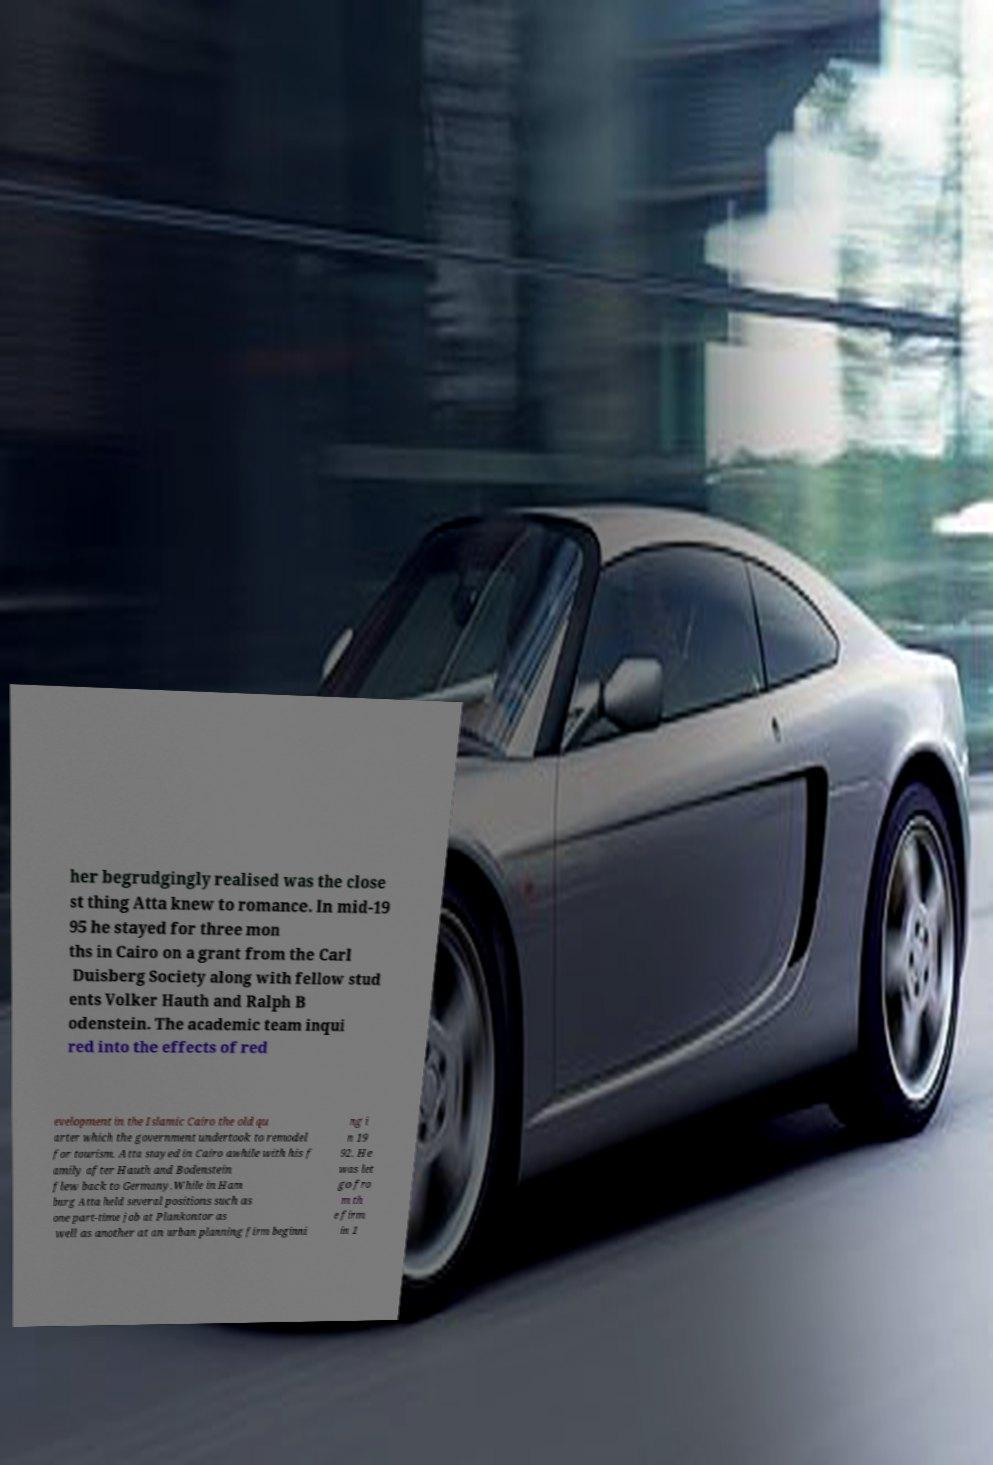Can you accurately transcribe the text from the provided image for me? her begrudgingly realised was the close st thing Atta knew to romance. In mid-19 95 he stayed for three mon ths in Cairo on a grant from the Carl Duisberg Society along with fellow stud ents Volker Hauth and Ralph B odenstein. The academic team inqui red into the effects of red evelopment in the Islamic Cairo the old qu arter which the government undertook to remodel for tourism. Atta stayed in Cairo awhile with his f amily after Hauth and Bodenstein flew back to Germany.While in Ham burg Atta held several positions such as one part-time job at Plankontor as well as another at an urban planning firm beginni ng i n 19 92. He was let go fro m th e firm in 1 